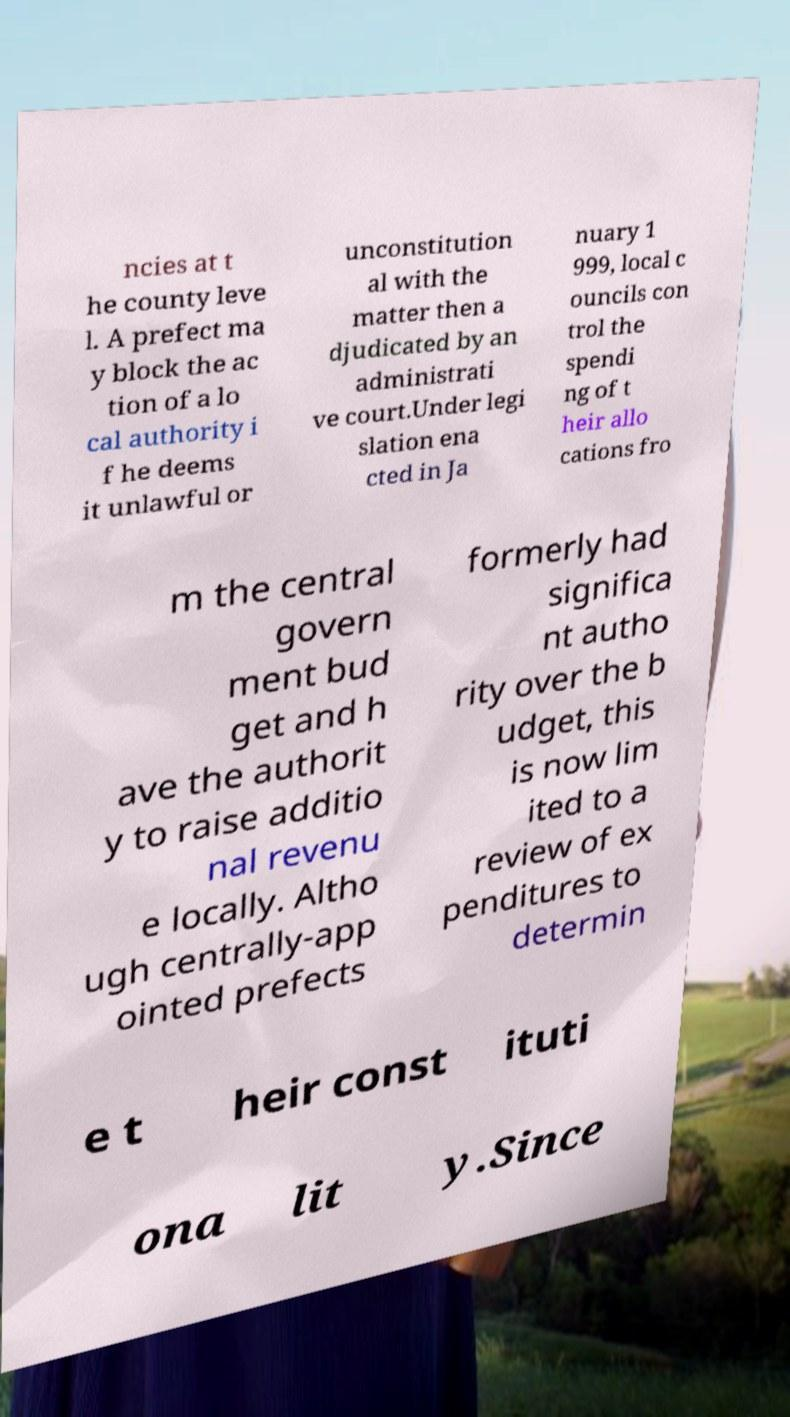For documentation purposes, I need the text within this image transcribed. Could you provide that? ncies at t he county leve l. A prefect ma y block the ac tion of a lo cal authority i f he deems it unlawful or unconstitution al with the matter then a djudicated by an administrati ve court.Under legi slation ena cted in Ja nuary 1 999, local c ouncils con trol the spendi ng of t heir allo cations fro m the central govern ment bud get and h ave the authorit y to raise additio nal revenu e locally. Altho ugh centrally-app ointed prefects formerly had significa nt autho rity over the b udget, this is now lim ited to a review of ex penditures to determin e t heir const ituti ona lit y.Since 